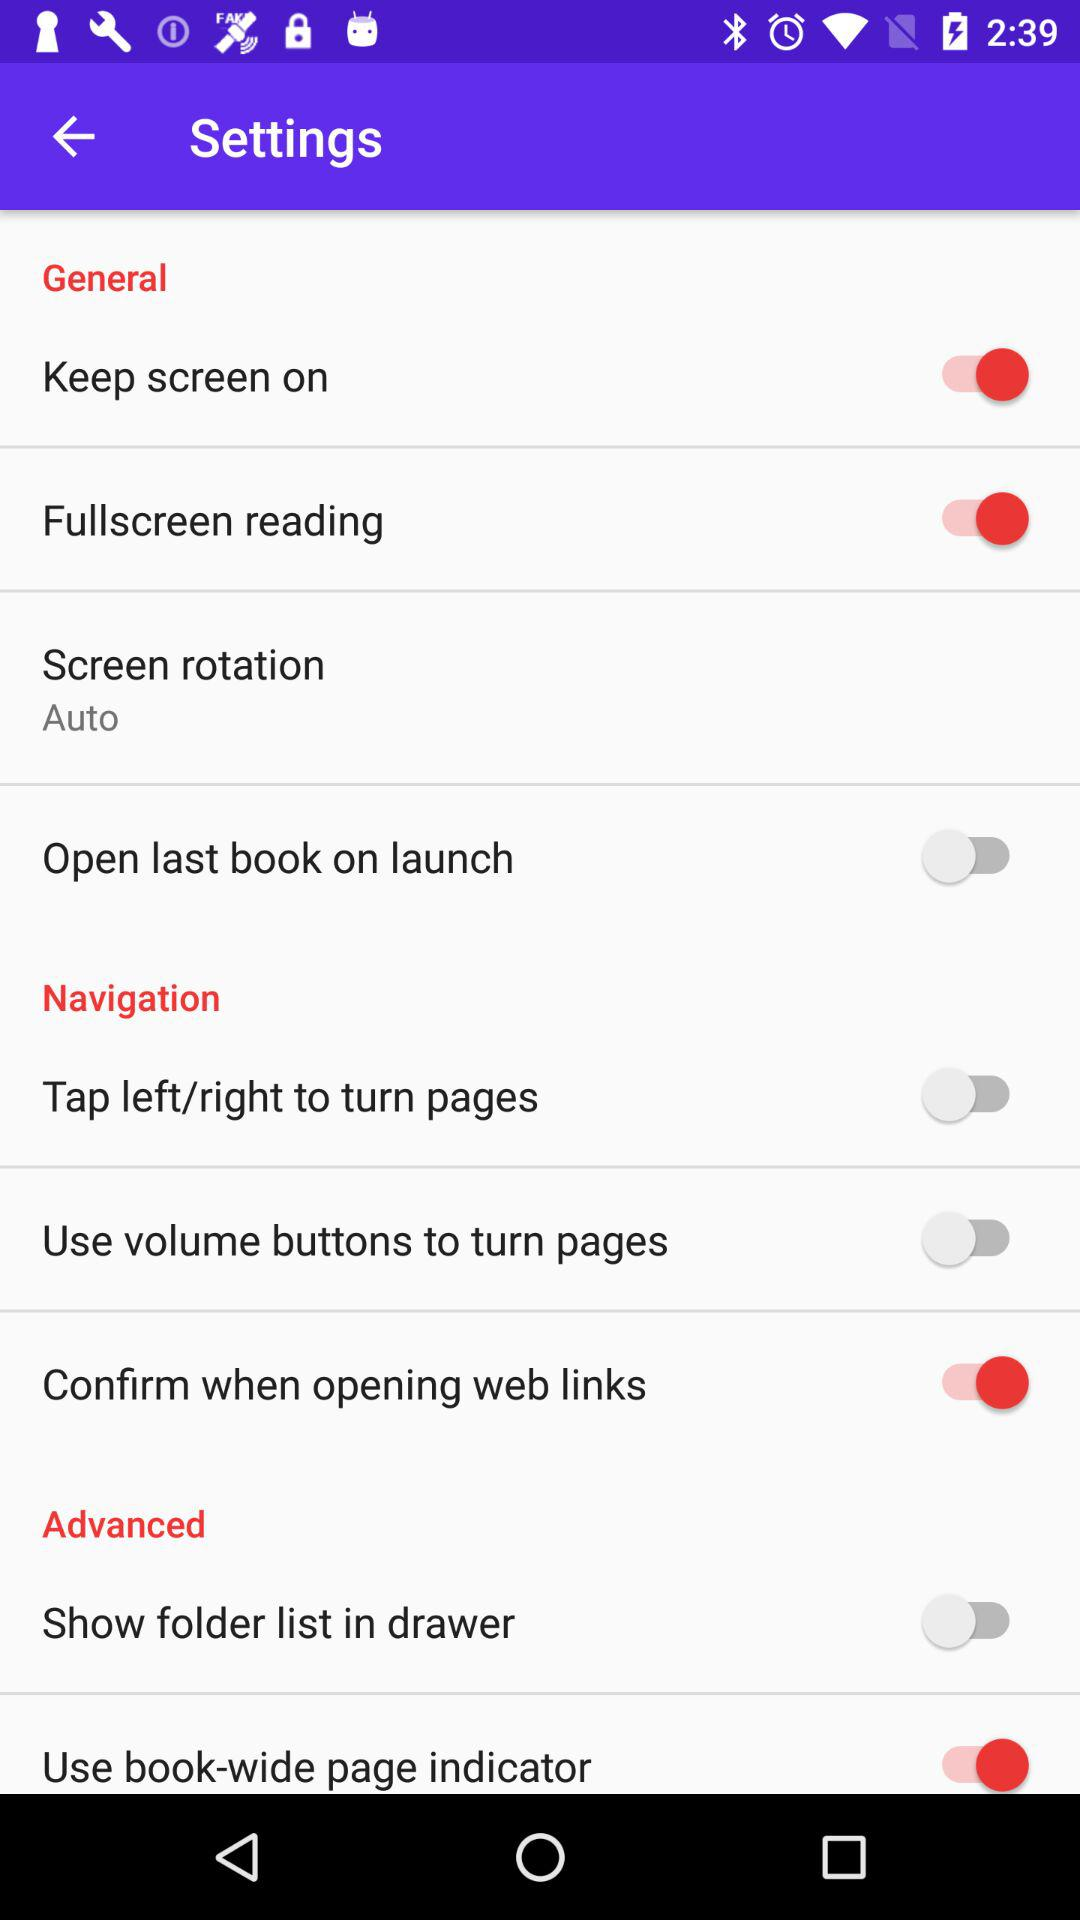What is the status of "Keep screen on"? The status of "Keep screen on" is "on". 